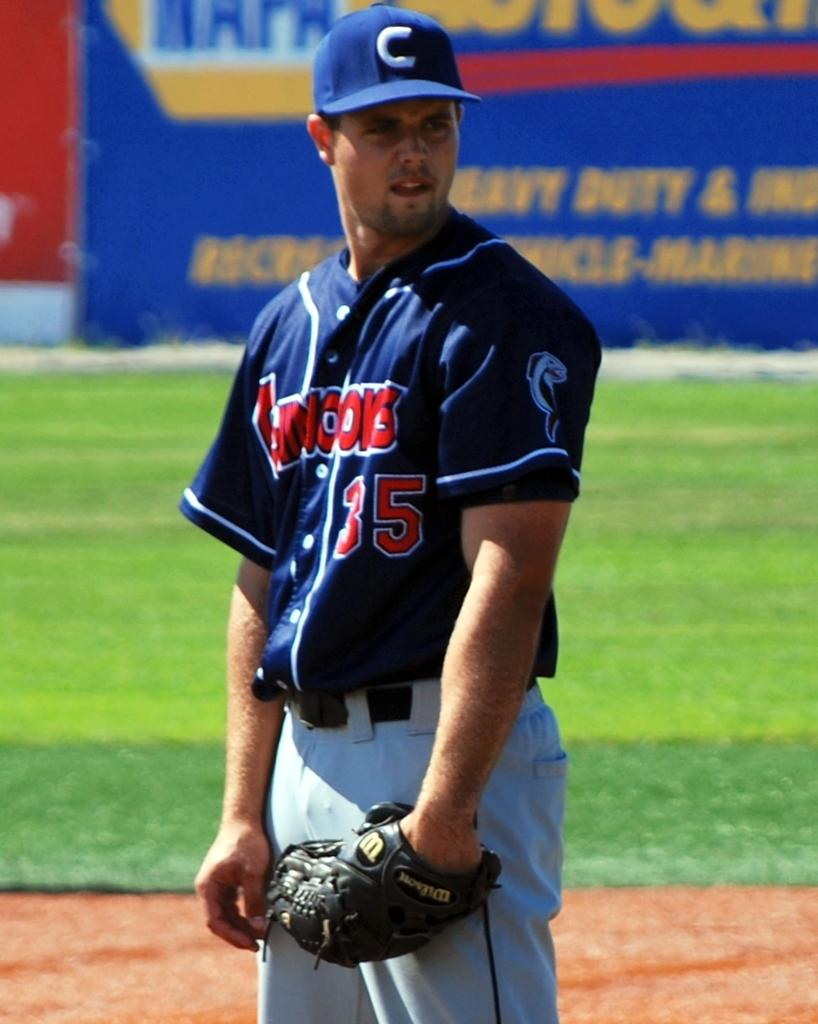<image>
Relay a brief, clear account of the picture shown. A baseball player wearing a blue jersey and the number 35 looks ready to play. 